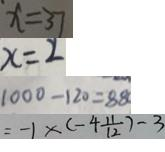Convert formula to latex. <formula><loc_0><loc_0><loc_500><loc_500>x = 3 7 
 x = 2 
 1 0 0 0 - 1 2 0 = 8 8 0 
 = - 1 \times ( - 4 \frac { 1 1 } { 1 2 } ) - 3</formula> 